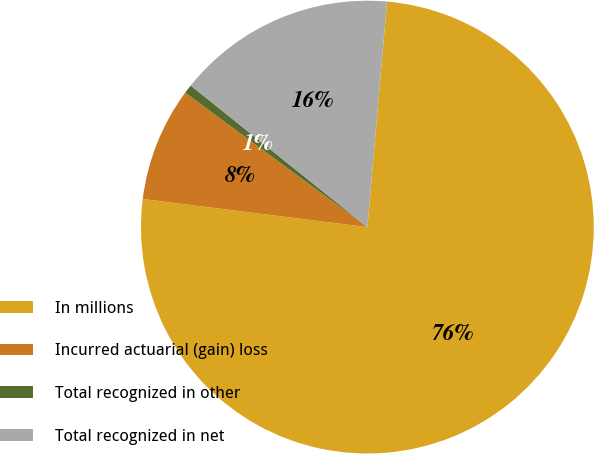Convert chart. <chart><loc_0><loc_0><loc_500><loc_500><pie_chart><fcel>In millions<fcel>Incurred actuarial (gain) loss<fcel>Total recognized in other<fcel>Total recognized in net<nl><fcel>75.6%<fcel>8.13%<fcel>0.64%<fcel>15.63%<nl></chart> 